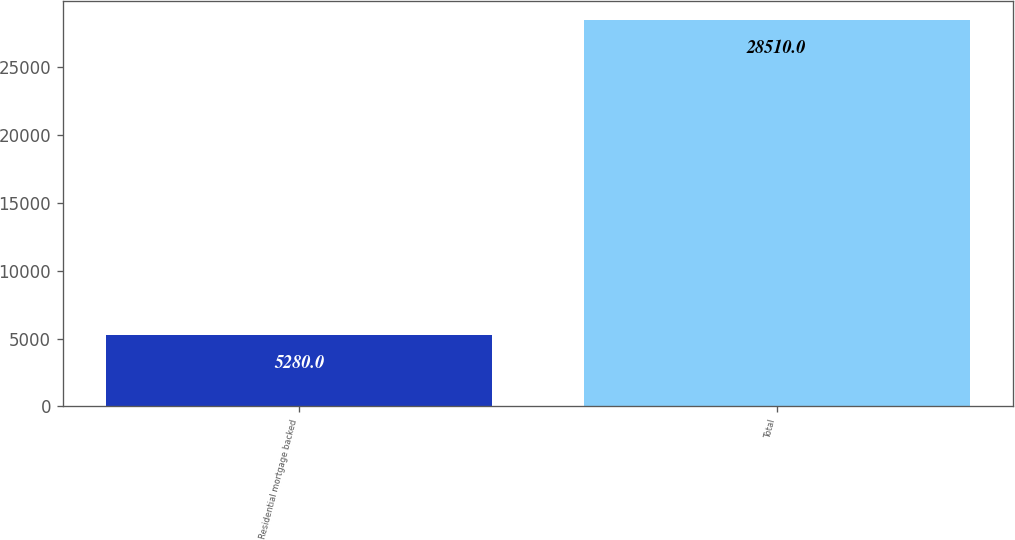Convert chart. <chart><loc_0><loc_0><loc_500><loc_500><bar_chart><fcel>Residential mortgage backed<fcel>Total<nl><fcel>5280<fcel>28510<nl></chart> 